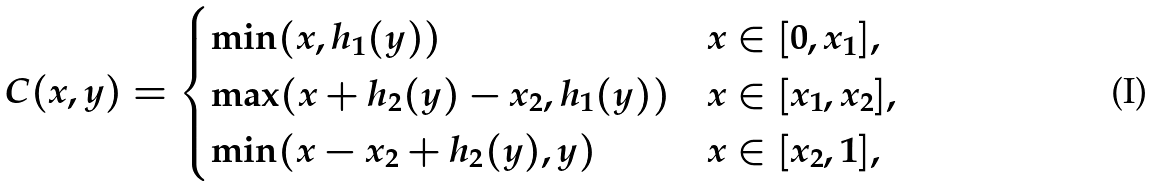<formula> <loc_0><loc_0><loc_500><loc_500>C ( x , y ) = \begin{cases} \min ( x , h _ { 1 } ( y ) ) & x \in [ 0 , x _ { 1 } ] , \\ \max ( x + h _ { 2 } ( y ) - x _ { 2 } , h _ { 1 } ( y ) ) & x \in [ x _ { 1 } , x _ { 2 } ] , \\ \min ( x - x _ { 2 } + h _ { 2 } ( y ) , y ) & x \in [ x _ { 2 } , 1 ] , \end{cases}</formula> 